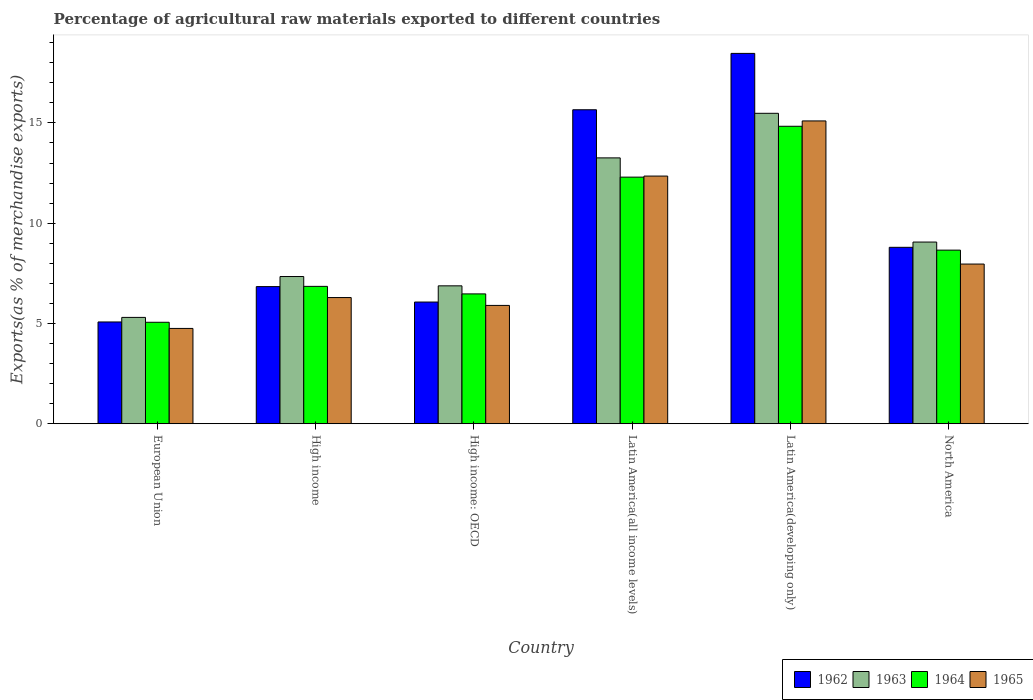How many groups of bars are there?
Provide a succinct answer. 6. Are the number of bars on each tick of the X-axis equal?
Provide a succinct answer. Yes. What is the label of the 1st group of bars from the left?
Make the answer very short. European Union. What is the percentage of exports to different countries in 1965 in High income?
Your answer should be very brief. 6.29. Across all countries, what is the maximum percentage of exports to different countries in 1965?
Make the answer very short. 15.1. Across all countries, what is the minimum percentage of exports to different countries in 1963?
Give a very brief answer. 5.3. In which country was the percentage of exports to different countries in 1965 maximum?
Your response must be concise. Latin America(developing only). In which country was the percentage of exports to different countries in 1964 minimum?
Ensure brevity in your answer.  European Union. What is the total percentage of exports to different countries in 1965 in the graph?
Give a very brief answer. 52.36. What is the difference between the percentage of exports to different countries in 1964 in European Union and that in North America?
Ensure brevity in your answer.  -3.6. What is the difference between the percentage of exports to different countries in 1962 in Latin America(all income levels) and the percentage of exports to different countries in 1965 in North America?
Make the answer very short. 7.69. What is the average percentage of exports to different countries in 1962 per country?
Give a very brief answer. 10.15. What is the difference between the percentage of exports to different countries of/in 1962 and percentage of exports to different countries of/in 1964 in High income: OECD?
Offer a very short reply. -0.41. In how many countries, is the percentage of exports to different countries in 1964 greater than 14 %?
Your answer should be very brief. 1. What is the ratio of the percentage of exports to different countries in 1962 in High income: OECD to that in North America?
Make the answer very short. 0.69. Is the difference between the percentage of exports to different countries in 1962 in High income: OECD and Latin America(developing only) greater than the difference between the percentage of exports to different countries in 1964 in High income: OECD and Latin America(developing only)?
Ensure brevity in your answer.  No. What is the difference between the highest and the second highest percentage of exports to different countries in 1964?
Keep it short and to the point. -3.64. What is the difference between the highest and the lowest percentage of exports to different countries in 1965?
Make the answer very short. 10.35. In how many countries, is the percentage of exports to different countries in 1964 greater than the average percentage of exports to different countries in 1964 taken over all countries?
Offer a terse response. 2. Is the sum of the percentage of exports to different countries in 1963 in European Union and North America greater than the maximum percentage of exports to different countries in 1965 across all countries?
Offer a terse response. No. What does the 3rd bar from the left in North America represents?
Provide a short and direct response. 1964. What does the 4th bar from the right in High income represents?
Provide a short and direct response. 1962. Is it the case that in every country, the sum of the percentage of exports to different countries in 1962 and percentage of exports to different countries in 1965 is greater than the percentage of exports to different countries in 1964?
Provide a succinct answer. Yes. How many bars are there?
Give a very brief answer. 24. Are all the bars in the graph horizontal?
Provide a short and direct response. No. How many countries are there in the graph?
Provide a succinct answer. 6. Does the graph contain any zero values?
Offer a terse response. No. Where does the legend appear in the graph?
Ensure brevity in your answer.  Bottom right. What is the title of the graph?
Offer a terse response. Percentage of agricultural raw materials exported to different countries. What is the label or title of the X-axis?
Keep it short and to the point. Country. What is the label or title of the Y-axis?
Your response must be concise. Exports(as % of merchandise exports). What is the Exports(as % of merchandise exports) in 1962 in European Union?
Ensure brevity in your answer.  5.08. What is the Exports(as % of merchandise exports) in 1963 in European Union?
Your response must be concise. 5.3. What is the Exports(as % of merchandise exports) in 1964 in European Union?
Your response must be concise. 5.06. What is the Exports(as % of merchandise exports) of 1965 in European Union?
Keep it short and to the point. 4.75. What is the Exports(as % of merchandise exports) in 1962 in High income?
Offer a very short reply. 6.84. What is the Exports(as % of merchandise exports) of 1963 in High income?
Provide a succinct answer. 7.34. What is the Exports(as % of merchandise exports) in 1964 in High income?
Your response must be concise. 6.85. What is the Exports(as % of merchandise exports) of 1965 in High income?
Offer a very short reply. 6.29. What is the Exports(as % of merchandise exports) of 1962 in High income: OECD?
Provide a succinct answer. 6.07. What is the Exports(as % of merchandise exports) of 1963 in High income: OECD?
Your answer should be very brief. 6.88. What is the Exports(as % of merchandise exports) of 1964 in High income: OECD?
Your answer should be compact. 6.47. What is the Exports(as % of merchandise exports) in 1965 in High income: OECD?
Offer a terse response. 5.9. What is the Exports(as % of merchandise exports) of 1962 in Latin America(all income levels)?
Offer a terse response. 15.66. What is the Exports(as % of merchandise exports) of 1963 in Latin America(all income levels)?
Provide a succinct answer. 13.26. What is the Exports(as % of merchandise exports) in 1964 in Latin America(all income levels)?
Make the answer very short. 12.3. What is the Exports(as % of merchandise exports) in 1965 in Latin America(all income levels)?
Offer a terse response. 12.35. What is the Exports(as % of merchandise exports) of 1962 in Latin America(developing only)?
Offer a terse response. 18.47. What is the Exports(as % of merchandise exports) of 1963 in Latin America(developing only)?
Ensure brevity in your answer.  15.48. What is the Exports(as % of merchandise exports) of 1964 in Latin America(developing only)?
Your answer should be very brief. 14.83. What is the Exports(as % of merchandise exports) in 1965 in Latin America(developing only)?
Ensure brevity in your answer.  15.1. What is the Exports(as % of merchandise exports) of 1962 in North America?
Offer a very short reply. 8.8. What is the Exports(as % of merchandise exports) in 1963 in North America?
Offer a terse response. 9.06. What is the Exports(as % of merchandise exports) of 1964 in North America?
Your response must be concise. 8.66. What is the Exports(as % of merchandise exports) of 1965 in North America?
Ensure brevity in your answer.  7.96. Across all countries, what is the maximum Exports(as % of merchandise exports) of 1962?
Your response must be concise. 18.47. Across all countries, what is the maximum Exports(as % of merchandise exports) of 1963?
Offer a very short reply. 15.48. Across all countries, what is the maximum Exports(as % of merchandise exports) of 1964?
Keep it short and to the point. 14.83. Across all countries, what is the maximum Exports(as % of merchandise exports) of 1965?
Your answer should be very brief. 15.1. Across all countries, what is the minimum Exports(as % of merchandise exports) of 1962?
Make the answer very short. 5.08. Across all countries, what is the minimum Exports(as % of merchandise exports) of 1963?
Offer a very short reply. 5.3. Across all countries, what is the minimum Exports(as % of merchandise exports) in 1964?
Give a very brief answer. 5.06. Across all countries, what is the minimum Exports(as % of merchandise exports) of 1965?
Offer a terse response. 4.75. What is the total Exports(as % of merchandise exports) in 1962 in the graph?
Ensure brevity in your answer.  60.91. What is the total Exports(as % of merchandise exports) in 1963 in the graph?
Ensure brevity in your answer.  57.32. What is the total Exports(as % of merchandise exports) of 1964 in the graph?
Provide a short and direct response. 54.17. What is the total Exports(as % of merchandise exports) of 1965 in the graph?
Your response must be concise. 52.36. What is the difference between the Exports(as % of merchandise exports) in 1962 in European Union and that in High income?
Give a very brief answer. -1.76. What is the difference between the Exports(as % of merchandise exports) of 1963 in European Union and that in High income?
Your answer should be very brief. -2.04. What is the difference between the Exports(as % of merchandise exports) of 1964 in European Union and that in High income?
Provide a succinct answer. -1.79. What is the difference between the Exports(as % of merchandise exports) in 1965 in European Union and that in High income?
Give a very brief answer. -1.54. What is the difference between the Exports(as % of merchandise exports) in 1962 in European Union and that in High income: OECD?
Provide a short and direct response. -0.99. What is the difference between the Exports(as % of merchandise exports) of 1963 in European Union and that in High income: OECD?
Your response must be concise. -1.57. What is the difference between the Exports(as % of merchandise exports) in 1964 in European Union and that in High income: OECD?
Offer a terse response. -1.41. What is the difference between the Exports(as % of merchandise exports) of 1965 in European Union and that in High income: OECD?
Ensure brevity in your answer.  -1.15. What is the difference between the Exports(as % of merchandise exports) of 1962 in European Union and that in Latin America(all income levels)?
Make the answer very short. -10.58. What is the difference between the Exports(as % of merchandise exports) in 1963 in European Union and that in Latin America(all income levels)?
Offer a terse response. -7.95. What is the difference between the Exports(as % of merchandise exports) of 1964 in European Union and that in Latin America(all income levels)?
Your answer should be compact. -7.24. What is the difference between the Exports(as % of merchandise exports) in 1965 in European Union and that in Latin America(all income levels)?
Your answer should be compact. -7.6. What is the difference between the Exports(as % of merchandise exports) in 1962 in European Union and that in Latin America(developing only)?
Provide a short and direct response. -13.39. What is the difference between the Exports(as % of merchandise exports) of 1963 in European Union and that in Latin America(developing only)?
Provide a short and direct response. -10.18. What is the difference between the Exports(as % of merchandise exports) in 1964 in European Union and that in Latin America(developing only)?
Ensure brevity in your answer.  -9.77. What is the difference between the Exports(as % of merchandise exports) of 1965 in European Union and that in Latin America(developing only)?
Your answer should be compact. -10.35. What is the difference between the Exports(as % of merchandise exports) in 1962 in European Union and that in North America?
Give a very brief answer. -3.72. What is the difference between the Exports(as % of merchandise exports) of 1963 in European Union and that in North America?
Make the answer very short. -3.76. What is the difference between the Exports(as % of merchandise exports) of 1964 in European Union and that in North America?
Provide a succinct answer. -3.6. What is the difference between the Exports(as % of merchandise exports) in 1965 in European Union and that in North America?
Provide a short and direct response. -3.21. What is the difference between the Exports(as % of merchandise exports) in 1962 in High income and that in High income: OECD?
Your answer should be very brief. 0.77. What is the difference between the Exports(as % of merchandise exports) of 1963 in High income and that in High income: OECD?
Keep it short and to the point. 0.46. What is the difference between the Exports(as % of merchandise exports) in 1964 in High income and that in High income: OECD?
Provide a succinct answer. 0.38. What is the difference between the Exports(as % of merchandise exports) of 1965 in High income and that in High income: OECD?
Keep it short and to the point. 0.39. What is the difference between the Exports(as % of merchandise exports) of 1962 in High income and that in Latin America(all income levels)?
Your response must be concise. -8.82. What is the difference between the Exports(as % of merchandise exports) of 1963 in High income and that in Latin America(all income levels)?
Ensure brevity in your answer.  -5.92. What is the difference between the Exports(as % of merchandise exports) in 1964 in High income and that in Latin America(all income levels)?
Offer a terse response. -5.45. What is the difference between the Exports(as % of merchandise exports) in 1965 in High income and that in Latin America(all income levels)?
Make the answer very short. -6.06. What is the difference between the Exports(as % of merchandise exports) in 1962 in High income and that in Latin America(developing only)?
Offer a terse response. -11.63. What is the difference between the Exports(as % of merchandise exports) in 1963 in High income and that in Latin America(developing only)?
Offer a terse response. -8.14. What is the difference between the Exports(as % of merchandise exports) in 1964 in High income and that in Latin America(developing only)?
Your answer should be compact. -7.98. What is the difference between the Exports(as % of merchandise exports) of 1965 in High income and that in Latin America(developing only)?
Your answer should be compact. -8.81. What is the difference between the Exports(as % of merchandise exports) of 1962 in High income and that in North America?
Your response must be concise. -1.96. What is the difference between the Exports(as % of merchandise exports) in 1963 in High income and that in North America?
Your response must be concise. -1.72. What is the difference between the Exports(as % of merchandise exports) in 1964 in High income and that in North America?
Offer a terse response. -1.81. What is the difference between the Exports(as % of merchandise exports) of 1965 in High income and that in North America?
Make the answer very short. -1.67. What is the difference between the Exports(as % of merchandise exports) in 1962 in High income: OECD and that in Latin America(all income levels)?
Offer a very short reply. -9.59. What is the difference between the Exports(as % of merchandise exports) in 1963 in High income: OECD and that in Latin America(all income levels)?
Offer a very short reply. -6.38. What is the difference between the Exports(as % of merchandise exports) in 1964 in High income: OECD and that in Latin America(all income levels)?
Keep it short and to the point. -5.82. What is the difference between the Exports(as % of merchandise exports) of 1965 in High income: OECD and that in Latin America(all income levels)?
Give a very brief answer. -6.45. What is the difference between the Exports(as % of merchandise exports) of 1962 in High income: OECD and that in Latin America(developing only)?
Offer a terse response. -12.4. What is the difference between the Exports(as % of merchandise exports) in 1963 in High income: OECD and that in Latin America(developing only)?
Ensure brevity in your answer.  -8.6. What is the difference between the Exports(as % of merchandise exports) of 1964 in High income: OECD and that in Latin America(developing only)?
Your answer should be very brief. -8.36. What is the difference between the Exports(as % of merchandise exports) in 1965 in High income: OECD and that in Latin America(developing only)?
Provide a short and direct response. -9.2. What is the difference between the Exports(as % of merchandise exports) in 1962 in High income: OECD and that in North America?
Provide a succinct answer. -2.73. What is the difference between the Exports(as % of merchandise exports) in 1963 in High income: OECD and that in North America?
Ensure brevity in your answer.  -2.18. What is the difference between the Exports(as % of merchandise exports) in 1964 in High income: OECD and that in North America?
Provide a short and direct response. -2.18. What is the difference between the Exports(as % of merchandise exports) of 1965 in High income: OECD and that in North America?
Offer a terse response. -2.06. What is the difference between the Exports(as % of merchandise exports) of 1962 in Latin America(all income levels) and that in Latin America(developing only)?
Provide a short and direct response. -2.81. What is the difference between the Exports(as % of merchandise exports) in 1963 in Latin America(all income levels) and that in Latin America(developing only)?
Ensure brevity in your answer.  -2.22. What is the difference between the Exports(as % of merchandise exports) of 1964 in Latin America(all income levels) and that in Latin America(developing only)?
Your answer should be compact. -2.54. What is the difference between the Exports(as % of merchandise exports) in 1965 in Latin America(all income levels) and that in Latin America(developing only)?
Make the answer very short. -2.75. What is the difference between the Exports(as % of merchandise exports) in 1962 in Latin America(all income levels) and that in North America?
Your response must be concise. 6.86. What is the difference between the Exports(as % of merchandise exports) in 1963 in Latin America(all income levels) and that in North America?
Offer a very short reply. 4.2. What is the difference between the Exports(as % of merchandise exports) of 1964 in Latin America(all income levels) and that in North America?
Offer a very short reply. 3.64. What is the difference between the Exports(as % of merchandise exports) in 1965 in Latin America(all income levels) and that in North America?
Provide a succinct answer. 4.39. What is the difference between the Exports(as % of merchandise exports) in 1962 in Latin America(developing only) and that in North America?
Offer a very short reply. 9.67. What is the difference between the Exports(as % of merchandise exports) of 1963 in Latin America(developing only) and that in North America?
Make the answer very short. 6.42. What is the difference between the Exports(as % of merchandise exports) in 1964 in Latin America(developing only) and that in North America?
Offer a terse response. 6.18. What is the difference between the Exports(as % of merchandise exports) in 1965 in Latin America(developing only) and that in North America?
Offer a terse response. 7.14. What is the difference between the Exports(as % of merchandise exports) of 1962 in European Union and the Exports(as % of merchandise exports) of 1963 in High income?
Your response must be concise. -2.27. What is the difference between the Exports(as % of merchandise exports) in 1962 in European Union and the Exports(as % of merchandise exports) in 1964 in High income?
Offer a terse response. -1.78. What is the difference between the Exports(as % of merchandise exports) of 1962 in European Union and the Exports(as % of merchandise exports) of 1965 in High income?
Provide a succinct answer. -1.22. What is the difference between the Exports(as % of merchandise exports) of 1963 in European Union and the Exports(as % of merchandise exports) of 1964 in High income?
Your response must be concise. -1.55. What is the difference between the Exports(as % of merchandise exports) in 1963 in European Union and the Exports(as % of merchandise exports) in 1965 in High income?
Your response must be concise. -0.99. What is the difference between the Exports(as % of merchandise exports) in 1964 in European Union and the Exports(as % of merchandise exports) in 1965 in High income?
Offer a very short reply. -1.23. What is the difference between the Exports(as % of merchandise exports) of 1962 in European Union and the Exports(as % of merchandise exports) of 1963 in High income: OECD?
Offer a terse response. -1.8. What is the difference between the Exports(as % of merchandise exports) of 1962 in European Union and the Exports(as % of merchandise exports) of 1964 in High income: OECD?
Your answer should be very brief. -1.4. What is the difference between the Exports(as % of merchandise exports) of 1962 in European Union and the Exports(as % of merchandise exports) of 1965 in High income: OECD?
Provide a short and direct response. -0.83. What is the difference between the Exports(as % of merchandise exports) of 1963 in European Union and the Exports(as % of merchandise exports) of 1964 in High income: OECD?
Give a very brief answer. -1.17. What is the difference between the Exports(as % of merchandise exports) in 1963 in European Union and the Exports(as % of merchandise exports) in 1965 in High income: OECD?
Your response must be concise. -0.6. What is the difference between the Exports(as % of merchandise exports) in 1964 in European Union and the Exports(as % of merchandise exports) in 1965 in High income: OECD?
Ensure brevity in your answer.  -0.84. What is the difference between the Exports(as % of merchandise exports) in 1962 in European Union and the Exports(as % of merchandise exports) in 1963 in Latin America(all income levels)?
Make the answer very short. -8.18. What is the difference between the Exports(as % of merchandise exports) in 1962 in European Union and the Exports(as % of merchandise exports) in 1964 in Latin America(all income levels)?
Ensure brevity in your answer.  -7.22. What is the difference between the Exports(as % of merchandise exports) in 1962 in European Union and the Exports(as % of merchandise exports) in 1965 in Latin America(all income levels)?
Provide a short and direct response. -7.28. What is the difference between the Exports(as % of merchandise exports) of 1963 in European Union and the Exports(as % of merchandise exports) of 1964 in Latin America(all income levels)?
Ensure brevity in your answer.  -7. What is the difference between the Exports(as % of merchandise exports) in 1963 in European Union and the Exports(as % of merchandise exports) in 1965 in Latin America(all income levels)?
Your answer should be very brief. -7.05. What is the difference between the Exports(as % of merchandise exports) in 1964 in European Union and the Exports(as % of merchandise exports) in 1965 in Latin America(all income levels)?
Offer a very short reply. -7.29. What is the difference between the Exports(as % of merchandise exports) in 1962 in European Union and the Exports(as % of merchandise exports) in 1963 in Latin America(developing only)?
Ensure brevity in your answer.  -10.41. What is the difference between the Exports(as % of merchandise exports) in 1962 in European Union and the Exports(as % of merchandise exports) in 1964 in Latin America(developing only)?
Ensure brevity in your answer.  -9.76. What is the difference between the Exports(as % of merchandise exports) in 1962 in European Union and the Exports(as % of merchandise exports) in 1965 in Latin America(developing only)?
Make the answer very short. -10.02. What is the difference between the Exports(as % of merchandise exports) of 1963 in European Union and the Exports(as % of merchandise exports) of 1964 in Latin America(developing only)?
Your answer should be compact. -9.53. What is the difference between the Exports(as % of merchandise exports) in 1963 in European Union and the Exports(as % of merchandise exports) in 1965 in Latin America(developing only)?
Your response must be concise. -9.8. What is the difference between the Exports(as % of merchandise exports) in 1964 in European Union and the Exports(as % of merchandise exports) in 1965 in Latin America(developing only)?
Make the answer very short. -10.04. What is the difference between the Exports(as % of merchandise exports) of 1962 in European Union and the Exports(as % of merchandise exports) of 1963 in North America?
Give a very brief answer. -3.98. What is the difference between the Exports(as % of merchandise exports) of 1962 in European Union and the Exports(as % of merchandise exports) of 1964 in North America?
Offer a very short reply. -3.58. What is the difference between the Exports(as % of merchandise exports) of 1962 in European Union and the Exports(as % of merchandise exports) of 1965 in North America?
Provide a succinct answer. -2.89. What is the difference between the Exports(as % of merchandise exports) of 1963 in European Union and the Exports(as % of merchandise exports) of 1964 in North America?
Provide a short and direct response. -3.35. What is the difference between the Exports(as % of merchandise exports) in 1963 in European Union and the Exports(as % of merchandise exports) in 1965 in North America?
Your answer should be compact. -2.66. What is the difference between the Exports(as % of merchandise exports) in 1964 in European Union and the Exports(as % of merchandise exports) in 1965 in North America?
Keep it short and to the point. -2.9. What is the difference between the Exports(as % of merchandise exports) in 1962 in High income and the Exports(as % of merchandise exports) in 1963 in High income: OECD?
Offer a terse response. -0.04. What is the difference between the Exports(as % of merchandise exports) of 1962 in High income and the Exports(as % of merchandise exports) of 1964 in High income: OECD?
Your answer should be compact. 0.36. What is the difference between the Exports(as % of merchandise exports) of 1962 in High income and the Exports(as % of merchandise exports) of 1965 in High income: OECD?
Provide a short and direct response. 0.94. What is the difference between the Exports(as % of merchandise exports) of 1963 in High income and the Exports(as % of merchandise exports) of 1964 in High income: OECD?
Ensure brevity in your answer.  0.87. What is the difference between the Exports(as % of merchandise exports) of 1963 in High income and the Exports(as % of merchandise exports) of 1965 in High income: OECD?
Offer a very short reply. 1.44. What is the difference between the Exports(as % of merchandise exports) in 1962 in High income and the Exports(as % of merchandise exports) in 1963 in Latin America(all income levels)?
Keep it short and to the point. -6.42. What is the difference between the Exports(as % of merchandise exports) of 1962 in High income and the Exports(as % of merchandise exports) of 1964 in Latin America(all income levels)?
Provide a succinct answer. -5.46. What is the difference between the Exports(as % of merchandise exports) in 1962 in High income and the Exports(as % of merchandise exports) in 1965 in Latin America(all income levels)?
Your response must be concise. -5.51. What is the difference between the Exports(as % of merchandise exports) of 1963 in High income and the Exports(as % of merchandise exports) of 1964 in Latin America(all income levels)?
Give a very brief answer. -4.96. What is the difference between the Exports(as % of merchandise exports) in 1963 in High income and the Exports(as % of merchandise exports) in 1965 in Latin America(all income levels)?
Your response must be concise. -5.01. What is the difference between the Exports(as % of merchandise exports) in 1962 in High income and the Exports(as % of merchandise exports) in 1963 in Latin America(developing only)?
Ensure brevity in your answer.  -8.64. What is the difference between the Exports(as % of merchandise exports) in 1962 in High income and the Exports(as % of merchandise exports) in 1964 in Latin America(developing only)?
Keep it short and to the point. -8. What is the difference between the Exports(as % of merchandise exports) of 1962 in High income and the Exports(as % of merchandise exports) of 1965 in Latin America(developing only)?
Provide a short and direct response. -8.26. What is the difference between the Exports(as % of merchandise exports) in 1963 in High income and the Exports(as % of merchandise exports) in 1964 in Latin America(developing only)?
Offer a very short reply. -7.49. What is the difference between the Exports(as % of merchandise exports) in 1963 in High income and the Exports(as % of merchandise exports) in 1965 in Latin America(developing only)?
Your answer should be compact. -7.76. What is the difference between the Exports(as % of merchandise exports) of 1964 in High income and the Exports(as % of merchandise exports) of 1965 in Latin America(developing only)?
Provide a short and direct response. -8.25. What is the difference between the Exports(as % of merchandise exports) of 1962 in High income and the Exports(as % of merchandise exports) of 1963 in North America?
Offer a terse response. -2.22. What is the difference between the Exports(as % of merchandise exports) of 1962 in High income and the Exports(as % of merchandise exports) of 1964 in North America?
Give a very brief answer. -1.82. What is the difference between the Exports(as % of merchandise exports) of 1962 in High income and the Exports(as % of merchandise exports) of 1965 in North America?
Provide a short and direct response. -1.12. What is the difference between the Exports(as % of merchandise exports) of 1963 in High income and the Exports(as % of merchandise exports) of 1964 in North America?
Your answer should be very brief. -1.32. What is the difference between the Exports(as % of merchandise exports) of 1963 in High income and the Exports(as % of merchandise exports) of 1965 in North America?
Ensure brevity in your answer.  -0.62. What is the difference between the Exports(as % of merchandise exports) in 1964 in High income and the Exports(as % of merchandise exports) in 1965 in North America?
Offer a very short reply. -1.11. What is the difference between the Exports(as % of merchandise exports) of 1962 in High income: OECD and the Exports(as % of merchandise exports) of 1963 in Latin America(all income levels)?
Ensure brevity in your answer.  -7.19. What is the difference between the Exports(as % of merchandise exports) in 1962 in High income: OECD and the Exports(as % of merchandise exports) in 1964 in Latin America(all income levels)?
Give a very brief answer. -6.23. What is the difference between the Exports(as % of merchandise exports) in 1962 in High income: OECD and the Exports(as % of merchandise exports) in 1965 in Latin America(all income levels)?
Make the answer very short. -6.28. What is the difference between the Exports(as % of merchandise exports) of 1963 in High income: OECD and the Exports(as % of merchandise exports) of 1964 in Latin America(all income levels)?
Provide a short and direct response. -5.42. What is the difference between the Exports(as % of merchandise exports) in 1963 in High income: OECD and the Exports(as % of merchandise exports) in 1965 in Latin America(all income levels)?
Give a very brief answer. -5.47. What is the difference between the Exports(as % of merchandise exports) in 1964 in High income: OECD and the Exports(as % of merchandise exports) in 1965 in Latin America(all income levels)?
Provide a short and direct response. -5.88. What is the difference between the Exports(as % of merchandise exports) in 1962 in High income: OECD and the Exports(as % of merchandise exports) in 1963 in Latin America(developing only)?
Offer a very short reply. -9.41. What is the difference between the Exports(as % of merchandise exports) in 1962 in High income: OECD and the Exports(as % of merchandise exports) in 1964 in Latin America(developing only)?
Ensure brevity in your answer.  -8.76. What is the difference between the Exports(as % of merchandise exports) of 1962 in High income: OECD and the Exports(as % of merchandise exports) of 1965 in Latin America(developing only)?
Provide a succinct answer. -9.03. What is the difference between the Exports(as % of merchandise exports) of 1963 in High income: OECD and the Exports(as % of merchandise exports) of 1964 in Latin America(developing only)?
Ensure brevity in your answer.  -7.96. What is the difference between the Exports(as % of merchandise exports) in 1963 in High income: OECD and the Exports(as % of merchandise exports) in 1965 in Latin America(developing only)?
Your answer should be compact. -8.22. What is the difference between the Exports(as % of merchandise exports) in 1964 in High income: OECD and the Exports(as % of merchandise exports) in 1965 in Latin America(developing only)?
Keep it short and to the point. -8.63. What is the difference between the Exports(as % of merchandise exports) of 1962 in High income: OECD and the Exports(as % of merchandise exports) of 1963 in North America?
Ensure brevity in your answer.  -2.99. What is the difference between the Exports(as % of merchandise exports) in 1962 in High income: OECD and the Exports(as % of merchandise exports) in 1964 in North America?
Give a very brief answer. -2.59. What is the difference between the Exports(as % of merchandise exports) of 1962 in High income: OECD and the Exports(as % of merchandise exports) of 1965 in North America?
Give a very brief answer. -1.89. What is the difference between the Exports(as % of merchandise exports) of 1963 in High income: OECD and the Exports(as % of merchandise exports) of 1964 in North America?
Provide a succinct answer. -1.78. What is the difference between the Exports(as % of merchandise exports) in 1963 in High income: OECD and the Exports(as % of merchandise exports) in 1965 in North America?
Give a very brief answer. -1.09. What is the difference between the Exports(as % of merchandise exports) in 1964 in High income: OECD and the Exports(as % of merchandise exports) in 1965 in North America?
Ensure brevity in your answer.  -1.49. What is the difference between the Exports(as % of merchandise exports) in 1962 in Latin America(all income levels) and the Exports(as % of merchandise exports) in 1963 in Latin America(developing only)?
Provide a succinct answer. 0.18. What is the difference between the Exports(as % of merchandise exports) of 1962 in Latin America(all income levels) and the Exports(as % of merchandise exports) of 1964 in Latin America(developing only)?
Your answer should be compact. 0.82. What is the difference between the Exports(as % of merchandise exports) of 1962 in Latin America(all income levels) and the Exports(as % of merchandise exports) of 1965 in Latin America(developing only)?
Offer a terse response. 0.56. What is the difference between the Exports(as % of merchandise exports) in 1963 in Latin America(all income levels) and the Exports(as % of merchandise exports) in 1964 in Latin America(developing only)?
Offer a very short reply. -1.58. What is the difference between the Exports(as % of merchandise exports) of 1963 in Latin America(all income levels) and the Exports(as % of merchandise exports) of 1965 in Latin America(developing only)?
Your response must be concise. -1.84. What is the difference between the Exports(as % of merchandise exports) of 1964 in Latin America(all income levels) and the Exports(as % of merchandise exports) of 1965 in Latin America(developing only)?
Provide a succinct answer. -2.8. What is the difference between the Exports(as % of merchandise exports) in 1962 in Latin America(all income levels) and the Exports(as % of merchandise exports) in 1963 in North America?
Ensure brevity in your answer.  6.6. What is the difference between the Exports(as % of merchandise exports) of 1962 in Latin America(all income levels) and the Exports(as % of merchandise exports) of 1964 in North America?
Provide a short and direct response. 7. What is the difference between the Exports(as % of merchandise exports) of 1962 in Latin America(all income levels) and the Exports(as % of merchandise exports) of 1965 in North America?
Offer a very short reply. 7.69. What is the difference between the Exports(as % of merchandise exports) of 1963 in Latin America(all income levels) and the Exports(as % of merchandise exports) of 1965 in North America?
Offer a terse response. 5.29. What is the difference between the Exports(as % of merchandise exports) in 1964 in Latin America(all income levels) and the Exports(as % of merchandise exports) in 1965 in North America?
Your answer should be very brief. 4.33. What is the difference between the Exports(as % of merchandise exports) in 1962 in Latin America(developing only) and the Exports(as % of merchandise exports) in 1963 in North America?
Make the answer very short. 9.41. What is the difference between the Exports(as % of merchandise exports) of 1962 in Latin America(developing only) and the Exports(as % of merchandise exports) of 1964 in North America?
Give a very brief answer. 9.81. What is the difference between the Exports(as % of merchandise exports) in 1962 in Latin America(developing only) and the Exports(as % of merchandise exports) in 1965 in North America?
Make the answer very short. 10.51. What is the difference between the Exports(as % of merchandise exports) of 1963 in Latin America(developing only) and the Exports(as % of merchandise exports) of 1964 in North America?
Provide a succinct answer. 6.82. What is the difference between the Exports(as % of merchandise exports) of 1963 in Latin America(developing only) and the Exports(as % of merchandise exports) of 1965 in North America?
Offer a terse response. 7.52. What is the difference between the Exports(as % of merchandise exports) of 1964 in Latin America(developing only) and the Exports(as % of merchandise exports) of 1965 in North America?
Your response must be concise. 6.87. What is the average Exports(as % of merchandise exports) of 1962 per country?
Ensure brevity in your answer.  10.15. What is the average Exports(as % of merchandise exports) of 1963 per country?
Your answer should be very brief. 9.55. What is the average Exports(as % of merchandise exports) of 1964 per country?
Ensure brevity in your answer.  9.03. What is the average Exports(as % of merchandise exports) in 1965 per country?
Provide a short and direct response. 8.73. What is the difference between the Exports(as % of merchandise exports) in 1962 and Exports(as % of merchandise exports) in 1963 in European Union?
Give a very brief answer. -0.23. What is the difference between the Exports(as % of merchandise exports) in 1962 and Exports(as % of merchandise exports) in 1964 in European Union?
Make the answer very short. 0.02. What is the difference between the Exports(as % of merchandise exports) of 1962 and Exports(as % of merchandise exports) of 1965 in European Union?
Provide a succinct answer. 0.32. What is the difference between the Exports(as % of merchandise exports) in 1963 and Exports(as % of merchandise exports) in 1964 in European Union?
Provide a succinct answer. 0.24. What is the difference between the Exports(as % of merchandise exports) in 1963 and Exports(as % of merchandise exports) in 1965 in European Union?
Ensure brevity in your answer.  0.55. What is the difference between the Exports(as % of merchandise exports) in 1964 and Exports(as % of merchandise exports) in 1965 in European Union?
Keep it short and to the point. 0.31. What is the difference between the Exports(as % of merchandise exports) of 1962 and Exports(as % of merchandise exports) of 1963 in High income?
Make the answer very short. -0.5. What is the difference between the Exports(as % of merchandise exports) of 1962 and Exports(as % of merchandise exports) of 1964 in High income?
Keep it short and to the point. -0.01. What is the difference between the Exports(as % of merchandise exports) of 1962 and Exports(as % of merchandise exports) of 1965 in High income?
Your response must be concise. 0.55. What is the difference between the Exports(as % of merchandise exports) of 1963 and Exports(as % of merchandise exports) of 1964 in High income?
Make the answer very short. 0.49. What is the difference between the Exports(as % of merchandise exports) of 1963 and Exports(as % of merchandise exports) of 1965 in High income?
Keep it short and to the point. 1.05. What is the difference between the Exports(as % of merchandise exports) of 1964 and Exports(as % of merchandise exports) of 1965 in High income?
Your response must be concise. 0.56. What is the difference between the Exports(as % of merchandise exports) of 1962 and Exports(as % of merchandise exports) of 1963 in High income: OECD?
Keep it short and to the point. -0.81. What is the difference between the Exports(as % of merchandise exports) of 1962 and Exports(as % of merchandise exports) of 1964 in High income: OECD?
Offer a terse response. -0.41. What is the difference between the Exports(as % of merchandise exports) of 1962 and Exports(as % of merchandise exports) of 1965 in High income: OECD?
Provide a short and direct response. 0.17. What is the difference between the Exports(as % of merchandise exports) of 1963 and Exports(as % of merchandise exports) of 1964 in High income: OECD?
Provide a succinct answer. 0.4. What is the difference between the Exports(as % of merchandise exports) in 1963 and Exports(as % of merchandise exports) in 1965 in High income: OECD?
Keep it short and to the point. 0.98. What is the difference between the Exports(as % of merchandise exports) in 1964 and Exports(as % of merchandise exports) in 1965 in High income: OECD?
Your answer should be very brief. 0.57. What is the difference between the Exports(as % of merchandise exports) of 1962 and Exports(as % of merchandise exports) of 1963 in Latin America(all income levels)?
Make the answer very short. 2.4. What is the difference between the Exports(as % of merchandise exports) in 1962 and Exports(as % of merchandise exports) in 1964 in Latin America(all income levels)?
Offer a very short reply. 3.36. What is the difference between the Exports(as % of merchandise exports) of 1962 and Exports(as % of merchandise exports) of 1965 in Latin America(all income levels)?
Ensure brevity in your answer.  3.31. What is the difference between the Exports(as % of merchandise exports) in 1963 and Exports(as % of merchandise exports) in 1964 in Latin America(all income levels)?
Ensure brevity in your answer.  0.96. What is the difference between the Exports(as % of merchandise exports) in 1963 and Exports(as % of merchandise exports) in 1965 in Latin America(all income levels)?
Provide a short and direct response. 0.91. What is the difference between the Exports(as % of merchandise exports) in 1964 and Exports(as % of merchandise exports) in 1965 in Latin America(all income levels)?
Give a very brief answer. -0.05. What is the difference between the Exports(as % of merchandise exports) of 1962 and Exports(as % of merchandise exports) of 1963 in Latin America(developing only)?
Your response must be concise. 2.99. What is the difference between the Exports(as % of merchandise exports) in 1962 and Exports(as % of merchandise exports) in 1964 in Latin America(developing only)?
Make the answer very short. 3.63. What is the difference between the Exports(as % of merchandise exports) in 1962 and Exports(as % of merchandise exports) in 1965 in Latin America(developing only)?
Keep it short and to the point. 3.37. What is the difference between the Exports(as % of merchandise exports) in 1963 and Exports(as % of merchandise exports) in 1964 in Latin America(developing only)?
Keep it short and to the point. 0.65. What is the difference between the Exports(as % of merchandise exports) of 1963 and Exports(as % of merchandise exports) of 1965 in Latin America(developing only)?
Offer a terse response. 0.38. What is the difference between the Exports(as % of merchandise exports) of 1964 and Exports(as % of merchandise exports) of 1965 in Latin America(developing only)?
Ensure brevity in your answer.  -0.27. What is the difference between the Exports(as % of merchandise exports) of 1962 and Exports(as % of merchandise exports) of 1963 in North America?
Offer a very short reply. -0.26. What is the difference between the Exports(as % of merchandise exports) of 1962 and Exports(as % of merchandise exports) of 1964 in North America?
Ensure brevity in your answer.  0.14. What is the difference between the Exports(as % of merchandise exports) in 1962 and Exports(as % of merchandise exports) in 1965 in North America?
Provide a short and direct response. 0.83. What is the difference between the Exports(as % of merchandise exports) in 1963 and Exports(as % of merchandise exports) in 1964 in North America?
Provide a succinct answer. 0.4. What is the difference between the Exports(as % of merchandise exports) of 1963 and Exports(as % of merchandise exports) of 1965 in North America?
Give a very brief answer. 1.1. What is the difference between the Exports(as % of merchandise exports) of 1964 and Exports(as % of merchandise exports) of 1965 in North America?
Your answer should be compact. 0.69. What is the ratio of the Exports(as % of merchandise exports) in 1962 in European Union to that in High income?
Offer a very short reply. 0.74. What is the ratio of the Exports(as % of merchandise exports) of 1963 in European Union to that in High income?
Make the answer very short. 0.72. What is the ratio of the Exports(as % of merchandise exports) of 1964 in European Union to that in High income?
Your response must be concise. 0.74. What is the ratio of the Exports(as % of merchandise exports) of 1965 in European Union to that in High income?
Provide a short and direct response. 0.76. What is the ratio of the Exports(as % of merchandise exports) of 1962 in European Union to that in High income: OECD?
Offer a very short reply. 0.84. What is the ratio of the Exports(as % of merchandise exports) in 1963 in European Union to that in High income: OECD?
Make the answer very short. 0.77. What is the ratio of the Exports(as % of merchandise exports) of 1964 in European Union to that in High income: OECD?
Provide a succinct answer. 0.78. What is the ratio of the Exports(as % of merchandise exports) in 1965 in European Union to that in High income: OECD?
Keep it short and to the point. 0.81. What is the ratio of the Exports(as % of merchandise exports) of 1962 in European Union to that in Latin America(all income levels)?
Keep it short and to the point. 0.32. What is the ratio of the Exports(as % of merchandise exports) in 1964 in European Union to that in Latin America(all income levels)?
Offer a terse response. 0.41. What is the ratio of the Exports(as % of merchandise exports) of 1965 in European Union to that in Latin America(all income levels)?
Make the answer very short. 0.38. What is the ratio of the Exports(as % of merchandise exports) in 1962 in European Union to that in Latin America(developing only)?
Ensure brevity in your answer.  0.27. What is the ratio of the Exports(as % of merchandise exports) in 1963 in European Union to that in Latin America(developing only)?
Provide a succinct answer. 0.34. What is the ratio of the Exports(as % of merchandise exports) of 1964 in European Union to that in Latin America(developing only)?
Your answer should be compact. 0.34. What is the ratio of the Exports(as % of merchandise exports) of 1965 in European Union to that in Latin America(developing only)?
Offer a very short reply. 0.31. What is the ratio of the Exports(as % of merchandise exports) in 1962 in European Union to that in North America?
Your answer should be very brief. 0.58. What is the ratio of the Exports(as % of merchandise exports) of 1963 in European Union to that in North America?
Keep it short and to the point. 0.59. What is the ratio of the Exports(as % of merchandise exports) in 1964 in European Union to that in North America?
Keep it short and to the point. 0.58. What is the ratio of the Exports(as % of merchandise exports) of 1965 in European Union to that in North America?
Provide a succinct answer. 0.6. What is the ratio of the Exports(as % of merchandise exports) in 1962 in High income to that in High income: OECD?
Provide a succinct answer. 1.13. What is the ratio of the Exports(as % of merchandise exports) of 1963 in High income to that in High income: OECD?
Ensure brevity in your answer.  1.07. What is the ratio of the Exports(as % of merchandise exports) in 1964 in High income to that in High income: OECD?
Give a very brief answer. 1.06. What is the ratio of the Exports(as % of merchandise exports) in 1965 in High income to that in High income: OECD?
Give a very brief answer. 1.07. What is the ratio of the Exports(as % of merchandise exports) of 1962 in High income to that in Latin America(all income levels)?
Your answer should be very brief. 0.44. What is the ratio of the Exports(as % of merchandise exports) in 1963 in High income to that in Latin America(all income levels)?
Offer a terse response. 0.55. What is the ratio of the Exports(as % of merchandise exports) in 1964 in High income to that in Latin America(all income levels)?
Make the answer very short. 0.56. What is the ratio of the Exports(as % of merchandise exports) in 1965 in High income to that in Latin America(all income levels)?
Keep it short and to the point. 0.51. What is the ratio of the Exports(as % of merchandise exports) in 1962 in High income to that in Latin America(developing only)?
Provide a succinct answer. 0.37. What is the ratio of the Exports(as % of merchandise exports) of 1963 in High income to that in Latin America(developing only)?
Your answer should be compact. 0.47. What is the ratio of the Exports(as % of merchandise exports) of 1964 in High income to that in Latin America(developing only)?
Ensure brevity in your answer.  0.46. What is the ratio of the Exports(as % of merchandise exports) of 1965 in High income to that in Latin America(developing only)?
Your answer should be very brief. 0.42. What is the ratio of the Exports(as % of merchandise exports) of 1962 in High income to that in North America?
Offer a very short reply. 0.78. What is the ratio of the Exports(as % of merchandise exports) in 1963 in High income to that in North America?
Give a very brief answer. 0.81. What is the ratio of the Exports(as % of merchandise exports) of 1964 in High income to that in North America?
Provide a short and direct response. 0.79. What is the ratio of the Exports(as % of merchandise exports) in 1965 in High income to that in North America?
Ensure brevity in your answer.  0.79. What is the ratio of the Exports(as % of merchandise exports) of 1962 in High income: OECD to that in Latin America(all income levels)?
Your answer should be compact. 0.39. What is the ratio of the Exports(as % of merchandise exports) of 1963 in High income: OECD to that in Latin America(all income levels)?
Give a very brief answer. 0.52. What is the ratio of the Exports(as % of merchandise exports) of 1964 in High income: OECD to that in Latin America(all income levels)?
Your answer should be compact. 0.53. What is the ratio of the Exports(as % of merchandise exports) of 1965 in High income: OECD to that in Latin America(all income levels)?
Give a very brief answer. 0.48. What is the ratio of the Exports(as % of merchandise exports) of 1962 in High income: OECD to that in Latin America(developing only)?
Your answer should be very brief. 0.33. What is the ratio of the Exports(as % of merchandise exports) in 1963 in High income: OECD to that in Latin America(developing only)?
Your answer should be compact. 0.44. What is the ratio of the Exports(as % of merchandise exports) in 1964 in High income: OECD to that in Latin America(developing only)?
Your response must be concise. 0.44. What is the ratio of the Exports(as % of merchandise exports) of 1965 in High income: OECD to that in Latin America(developing only)?
Your answer should be compact. 0.39. What is the ratio of the Exports(as % of merchandise exports) of 1962 in High income: OECD to that in North America?
Keep it short and to the point. 0.69. What is the ratio of the Exports(as % of merchandise exports) in 1963 in High income: OECD to that in North America?
Your answer should be very brief. 0.76. What is the ratio of the Exports(as % of merchandise exports) of 1964 in High income: OECD to that in North America?
Provide a short and direct response. 0.75. What is the ratio of the Exports(as % of merchandise exports) in 1965 in High income: OECD to that in North America?
Give a very brief answer. 0.74. What is the ratio of the Exports(as % of merchandise exports) of 1962 in Latin America(all income levels) to that in Latin America(developing only)?
Offer a very short reply. 0.85. What is the ratio of the Exports(as % of merchandise exports) of 1963 in Latin America(all income levels) to that in Latin America(developing only)?
Your answer should be compact. 0.86. What is the ratio of the Exports(as % of merchandise exports) of 1964 in Latin America(all income levels) to that in Latin America(developing only)?
Your answer should be compact. 0.83. What is the ratio of the Exports(as % of merchandise exports) of 1965 in Latin America(all income levels) to that in Latin America(developing only)?
Your answer should be very brief. 0.82. What is the ratio of the Exports(as % of merchandise exports) in 1962 in Latin America(all income levels) to that in North America?
Keep it short and to the point. 1.78. What is the ratio of the Exports(as % of merchandise exports) of 1963 in Latin America(all income levels) to that in North America?
Ensure brevity in your answer.  1.46. What is the ratio of the Exports(as % of merchandise exports) of 1964 in Latin America(all income levels) to that in North America?
Your answer should be very brief. 1.42. What is the ratio of the Exports(as % of merchandise exports) in 1965 in Latin America(all income levels) to that in North America?
Give a very brief answer. 1.55. What is the ratio of the Exports(as % of merchandise exports) of 1962 in Latin America(developing only) to that in North America?
Provide a short and direct response. 2.1. What is the ratio of the Exports(as % of merchandise exports) of 1963 in Latin America(developing only) to that in North America?
Keep it short and to the point. 1.71. What is the ratio of the Exports(as % of merchandise exports) of 1964 in Latin America(developing only) to that in North America?
Offer a very short reply. 1.71. What is the ratio of the Exports(as % of merchandise exports) of 1965 in Latin America(developing only) to that in North America?
Your answer should be compact. 1.9. What is the difference between the highest and the second highest Exports(as % of merchandise exports) in 1962?
Make the answer very short. 2.81. What is the difference between the highest and the second highest Exports(as % of merchandise exports) of 1963?
Keep it short and to the point. 2.22. What is the difference between the highest and the second highest Exports(as % of merchandise exports) in 1964?
Offer a very short reply. 2.54. What is the difference between the highest and the second highest Exports(as % of merchandise exports) of 1965?
Your response must be concise. 2.75. What is the difference between the highest and the lowest Exports(as % of merchandise exports) in 1962?
Provide a succinct answer. 13.39. What is the difference between the highest and the lowest Exports(as % of merchandise exports) in 1963?
Your response must be concise. 10.18. What is the difference between the highest and the lowest Exports(as % of merchandise exports) in 1964?
Make the answer very short. 9.77. What is the difference between the highest and the lowest Exports(as % of merchandise exports) of 1965?
Give a very brief answer. 10.35. 